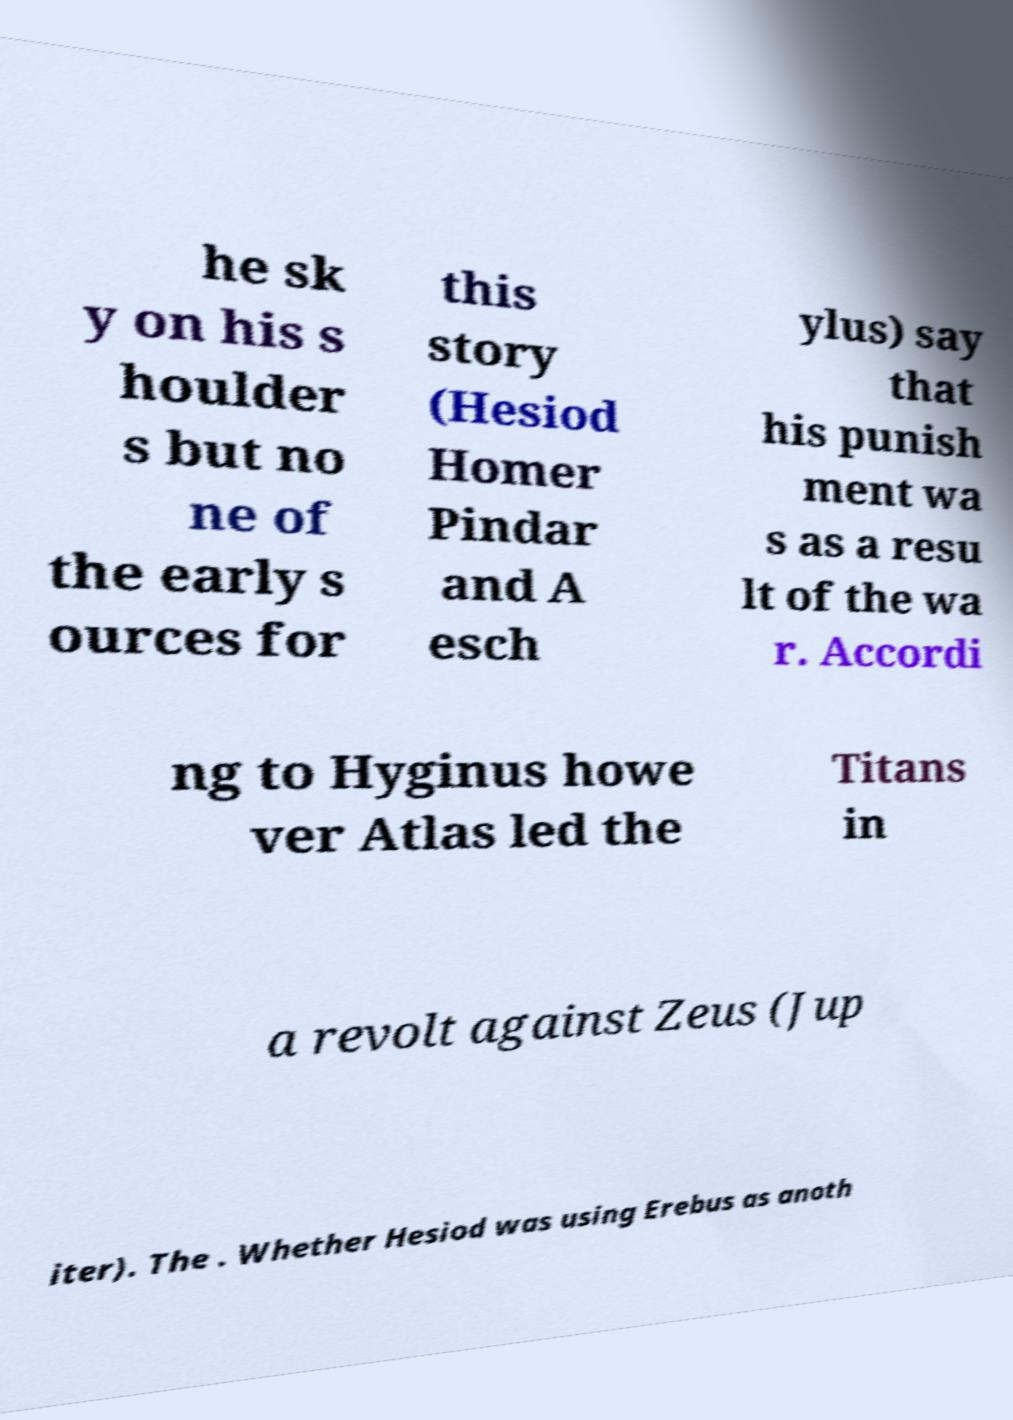What messages or text are displayed in this image? I need them in a readable, typed format. he sk y on his s houlder s but no ne of the early s ources for this story (Hesiod Homer Pindar and A esch ylus) say that his punish ment wa s as a resu lt of the wa r. Accordi ng to Hyginus howe ver Atlas led the Titans in a revolt against Zeus (Jup iter). The . Whether Hesiod was using Erebus as anoth 